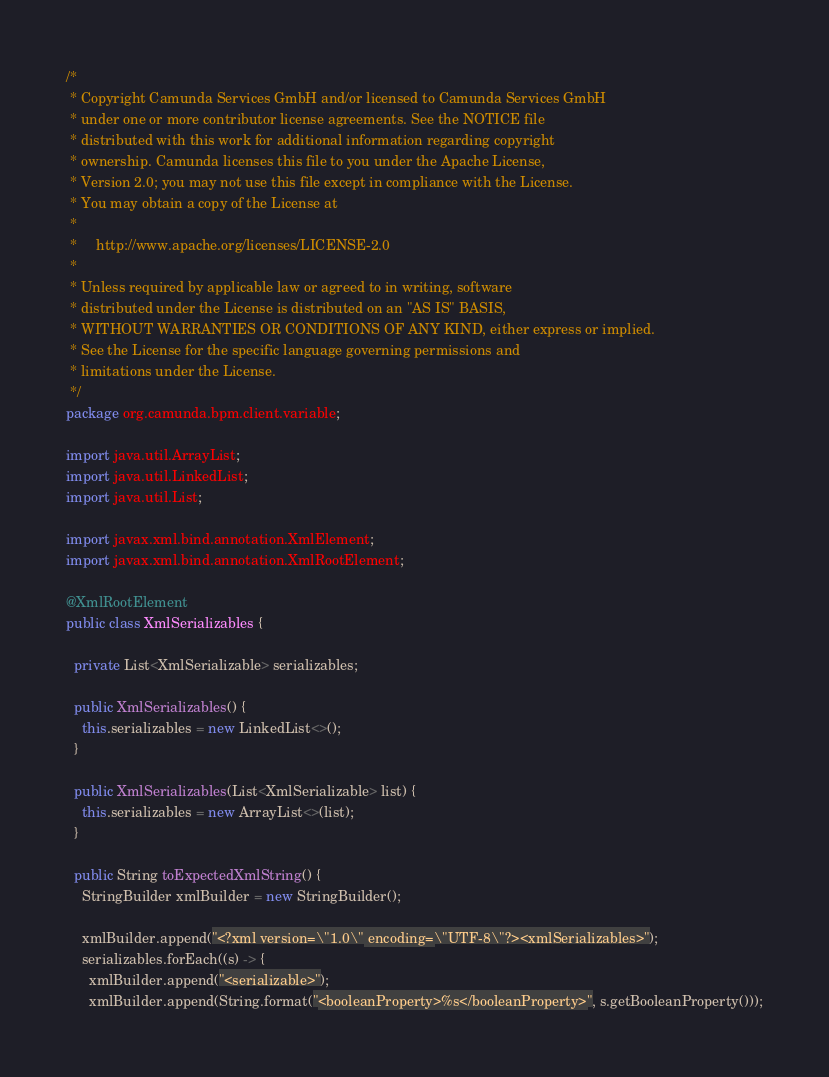Convert code to text. <code><loc_0><loc_0><loc_500><loc_500><_Java_>/*
 * Copyright Camunda Services GmbH and/or licensed to Camunda Services GmbH
 * under one or more contributor license agreements. See the NOTICE file
 * distributed with this work for additional information regarding copyright
 * ownership. Camunda licenses this file to you under the Apache License,
 * Version 2.0; you may not use this file except in compliance with the License.
 * You may obtain a copy of the License at
 *
 *     http://www.apache.org/licenses/LICENSE-2.0
 *
 * Unless required by applicable law or agreed to in writing, software
 * distributed under the License is distributed on an "AS IS" BASIS,
 * WITHOUT WARRANTIES OR CONDITIONS OF ANY KIND, either express or implied.
 * See the License for the specific language governing permissions and
 * limitations under the License.
 */
package org.camunda.bpm.client.variable;

import java.util.ArrayList;
import java.util.LinkedList;
import java.util.List;

import javax.xml.bind.annotation.XmlElement;
import javax.xml.bind.annotation.XmlRootElement;

@XmlRootElement
public class XmlSerializables {

  private List<XmlSerializable> serializables;

  public XmlSerializables() {
    this.serializables = new LinkedList<>();
  }

  public XmlSerializables(List<XmlSerializable> list) {
    this.serializables = new ArrayList<>(list);
  }

  public String toExpectedXmlString() {
    StringBuilder xmlBuilder = new StringBuilder();

    xmlBuilder.append("<?xml version=\"1.0\" encoding=\"UTF-8\"?><xmlSerializables>");
    serializables.forEach((s) -> {
      xmlBuilder.append("<serializable>");
      xmlBuilder.append(String.format("<booleanProperty>%s</booleanProperty>", s.getBooleanProperty()));</code> 